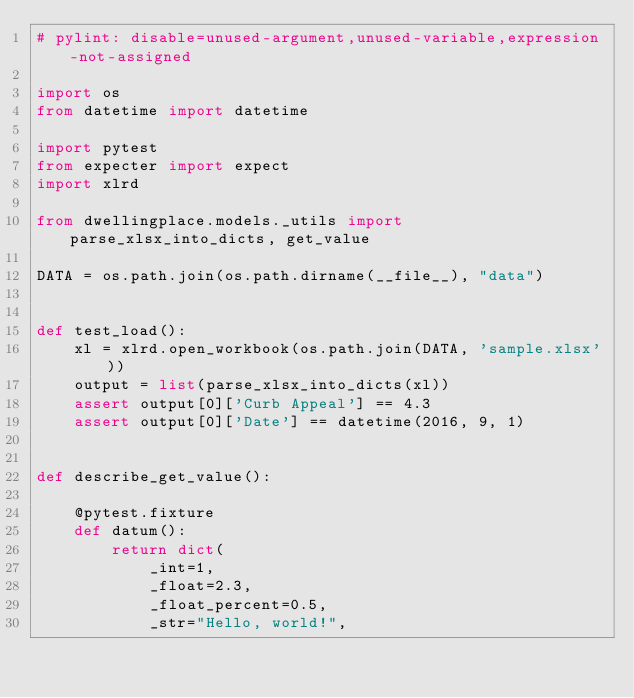<code> <loc_0><loc_0><loc_500><loc_500><_Python_># pylint: disable=unused-argument,unused-variable,expression-not-assigned

import os
from datetime import datetime

import pytest
from expecter import expect
import xlrd

from dwellingplace.models._utils import parse_xlsx_into_dicts, get_value

DATA = os.path.join(os.path.dirname(__file__), "data")


def test_load():
    xl = xlrd.open_workbook(os.path.join(DATA, 'sample.xlsx'))
    output = list(parse_xlsx_into_dicts(xl))
    assert output[0]['Curb Appeal'] == 4.3
    assert output[0]['Date'] == datetime(2016, 9, 1)


def describe_get_value():

    @pytest.fixture
    def datum():
        return dict(
            _int=1,
            _float=2.3,
            _float_percent=0.5,
            _str="Hello, world!",</code> 